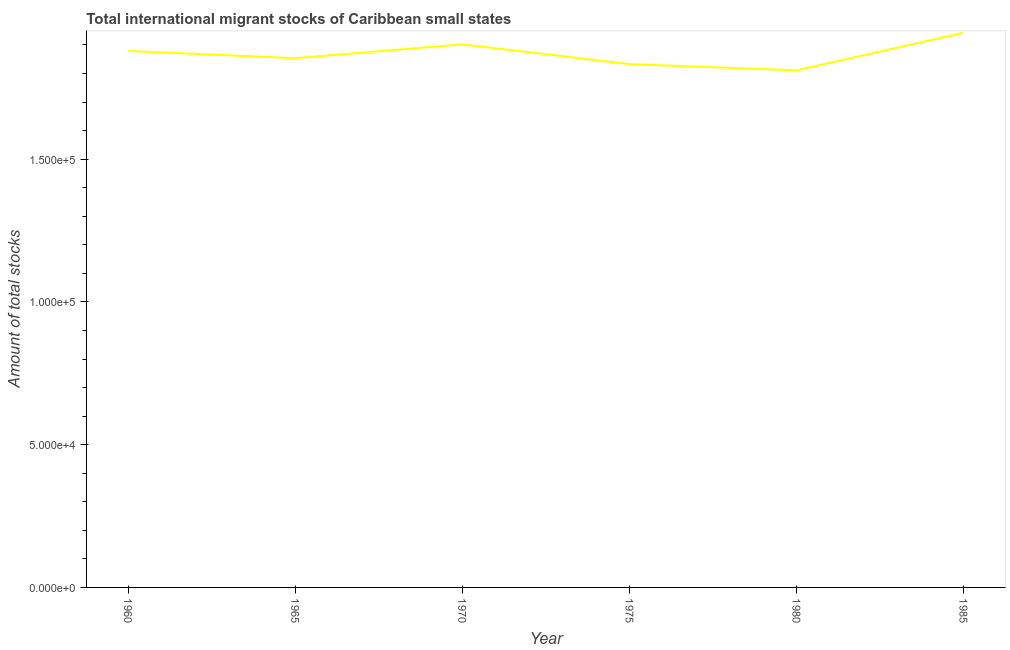What is the total number of international migrant stock in 1970?
Offer a very short reply. 1.90e+05. Across all years, what is the maximum total number of international migrant stock?
Offer a very short reply. 1.94e+05. Across all years, what is the minimum total number of international migrant stock?
Give a very brief answer. 1.81e+05. What is the sum of the total number of international migrant stock?
Your answer should be compact. 1.12e+06. What is the difference between the total number of international migrant stock in 1980 and 1985?
Offer a very short reply. -1.32e+04. What is the average total number of international migrant stock per year?
Your answer should be very brief. 1.87e+05. What is the median total number of international migrant stock?
Your answer should be compact. 1.87e+05. In how many years, is the total number of international migrant stock greater than 150000 ?
Give a very brief answer. 6. What is the ratio of the total number of international migrant stock in 1965 to that in 1980?
Your answer should be compact. 1.02. Is the total number of international migrant stock in 1970 less than that in 1980?
Provide a succinct answer. No. Is the difference between the total number of international migrant stock in 1980 and 1985 greater than the difference between any two years?
Your answer should be compact. Yes. What is the difference between the highest and the second highest total number of international migrant stock?
Keep it short and to the point. 4065. What is the difference between the highest and the lowest total number of international migrant stock?
Your answer should be compact. 1.32e+04. How many years are there in the graph?
Provide a succinct answer. 6. What is the difference between two consecutive major ticks on the Y-axis?
Give a very brief answer. 5.00e+04. Are the values on the major ticks of Y-axis written in scientific E-notation?
Your answer should be very brief. Yes. Does the graph contain any zero values?
Offer a terse response. No. What is the title of the graph?
Your answer should be compact. Total international migrant stocks of Caribbean small states. What is the label or title of the X-axis?
Give a very brief answer. Year. What is the label or title of the Y-axis?
Provide a short and direct response. Amount of total stocks. What is the Amount of total stocks of 1960?
Keep it short and to the point. 1.88e+05. What is the Amount of total stocks in 1965?
Ensure brevity in your answer.  1.85e+05. What is the Amount of total stocks in 1970?
Provide a short and direct response. 1.90e+05. What is the Amount of total stocks of 1975?
Your answer should be very brief. 1.83e+05. What is the Amount of total stocks in 1980?
Give a very brief answer. 1.81e+05. What is the Amount of total stocks in 1985?
Give a very brief answer. 1.94e+05. What is the difference between the Amount of total stocks in 1960 and 1965?
Keep it short and to the point. 2518. What is the difference between the Amount of total stocks in 1960 and 1970?
Offer a very short reply. -2337. What is the difference between the Amount of total stocks in 1960 and 1975?
Your response must be concise. 4601. What is the difference between the Amount of total stocks in 1960 and 1980?
Offer a very short reply. 6771. What is the difference between the Amount of total stocks in 1960 and 1985?
Give a very brief answer. -6402. What is the difference between the Amount of total stocks in 1965 and 1970?
Your answer should be compact. -4855. What is the difference between the Amount of total stocks in 1965 and 1975?
Offer a terse response. 2083. What is the difference between the Amount of total stocks in 1965 and 1980?
Your response must be concise. 4253. What is the difference between the Amount of total stocks in 1965 and 1985?
Offer a very short reply. -8920. What is the difference between the Amount of total stocks in 1970 and 1975?
Give a very brief answer. 6938. What is the difference between the Amount of total stocks in 1970 and 1980?
Your answer should be very brief. 9108. What is the difference between the Amount of total stocks in 1970 and 1985?
Your answer should be compact. -4065. What is the difference between the Amount of total stocks in 1975 and 1980?
Ensure brevity in your answer.  2170. What is the difference between the Amount of total stocks in 1975 and 1985?
Provide a short and direct response. -1.10e+04. What is the difference between the Amount of total stocks in 1980 and 1985?
Give a very brief answer. -1.32e+04. What is the ratio of the Amount of total stocks in 1960 to that in 1965?
Your answer should be compact. 1.01. What is the ratio of the Amount of total stocks in 1960 to that in 1970?
Keep it short and to the point. 0.99. What is the ratio of the Amount of total stocks in 1965 to that in 1970?
Provide a succinct answer. 0.97. What is the ratio of the Amount of total stocks in 1965 to that in 1980?
Ensure brevity in your answer.  1.02. What is the ratio of the Amount of total stocks in 1965 to that in 1985?
Provide a succinct answer. 0.95. What is the ratio of the Amount of total stocks in 1970 to that in 1975?
Keep it short and to the point. 1.04. What is the ratio of the Amount of total stocks in 1970 to that in 1985?
Offer a very short reply. 0.98. What is the ratio of the Amount of total stocks in 1975 to that in 1980?
Keep it short and to the point. 1.01. What is the ratio of the Amount of total stocks in 1975 to that in 1985?
Offer a very short reply. 0.94. What is the ratio of the Amount of total stocks in 1980 to that in 1985?
Your answer should be compact. 0.93. 